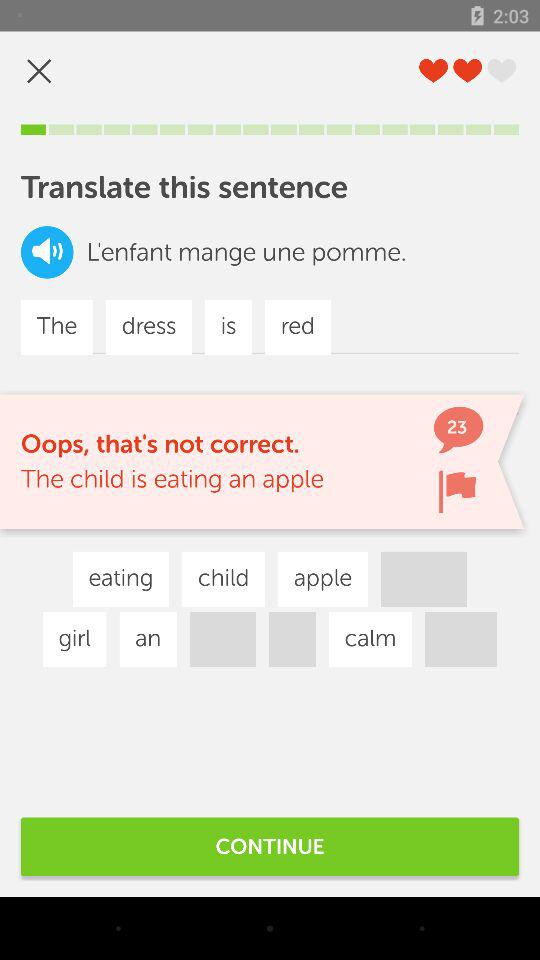What is the number of comments? The number of comments is 23. 